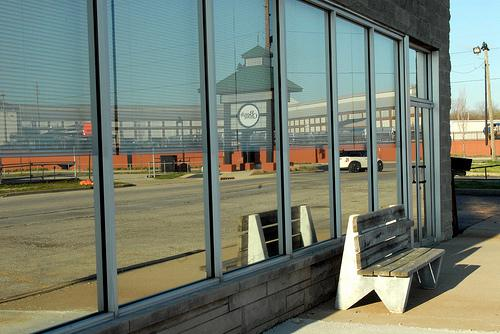Question: where is the bench?
Choices:
A. Park.
B. Sidewalk.
C. Basketball court.
D. Outside.
Answer with the letter. Answer: B Question: why is there a reflection of a car?
Choices:
A. Glass window.
B. The sun is shining.
C. Rain puddle.
D. Oil puddle.
Answer with the letter. Answer: A Question: what is inside the windows?
Choices:
A. Cat.
B. Blinds.
C. Glass.
D. Stickers.
Answer with the letter. Answer: B 